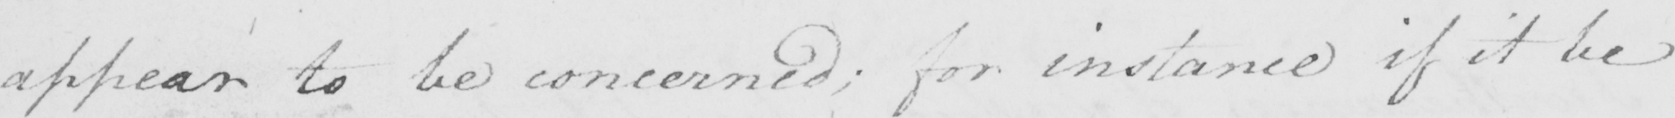Can you tell me what this handwritten text says? appear to be concerned ; for instance if it be 